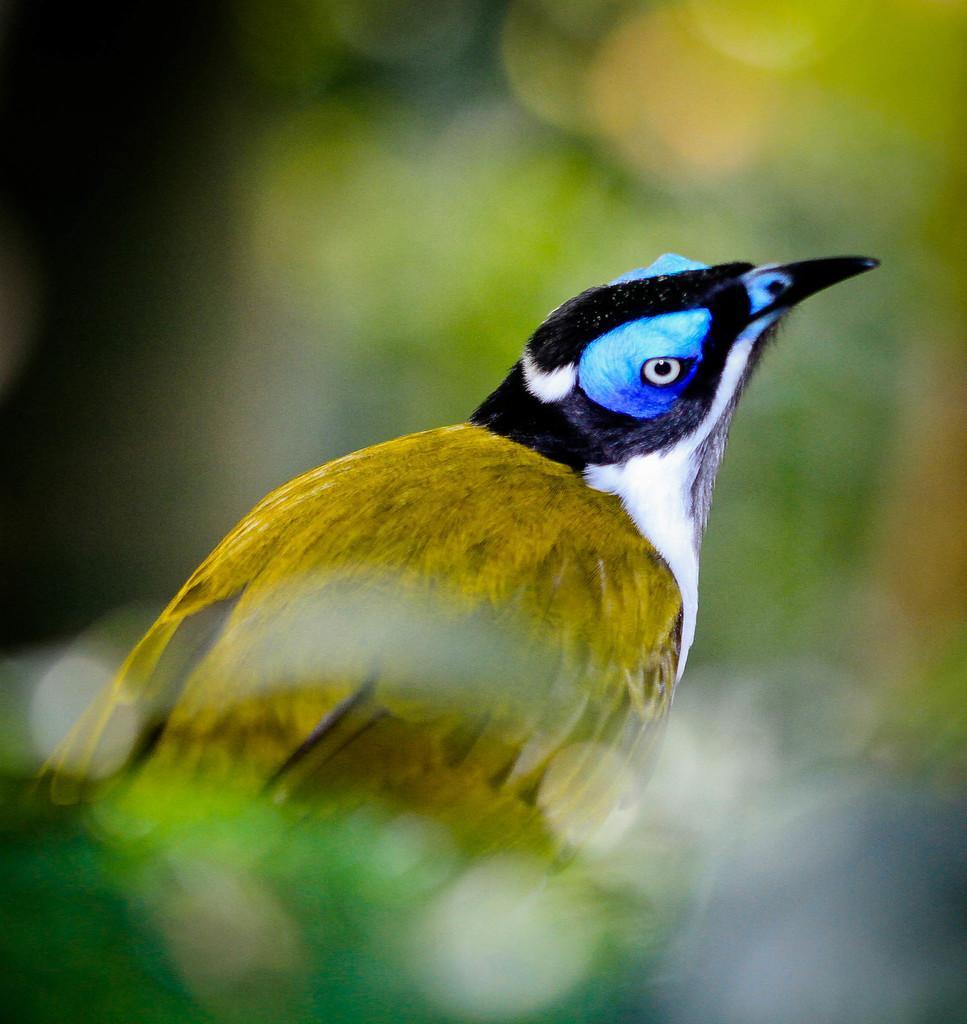How would you summarize this image in a sentence or two? In the center of the image we can see a bird. 